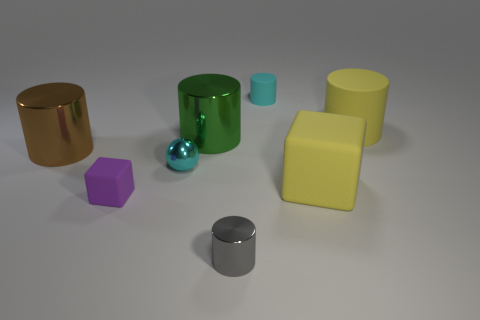Are there fewer matte cubes behind the brown metallic thing than yellow objects?
Offer a terse response. Yes. Are there any large cubes?
Provide a short and direct response. Yes. There is another big rubber object that is the same shape as the brown object; what color is it?
Provide a succinct answer. Yellow. There is a small metal object behind the gray metal cylinder; is its color the same as the tiny matte cylinder?
Ensure brevity in your answer.  Yes. Do the green shiny object and the cyan metal thing have the same size?
Give a very brief answer. No. There is a cyan thing that is the same material as the large brown cylinder; what shape is it?
Provide a short and direct response. Sphere. What number of other objects are the same shape as the big green shiny thing?
Your response must be concise. 4. The big yellow thing to the left of the yellow matte object that is behind the big green metallic cylinder that is to the left of the yellow rubber block is what shape?
Give a very brief answer. Cube. How many cylinders are either tiny cyan objects or small purple objects?
Ensure brevity in your answer.  1. Are there any small cyan shiny things in front of the cyan thing that is in front of the yellow rubber cylinder?
Provide a succinct answer. No. 